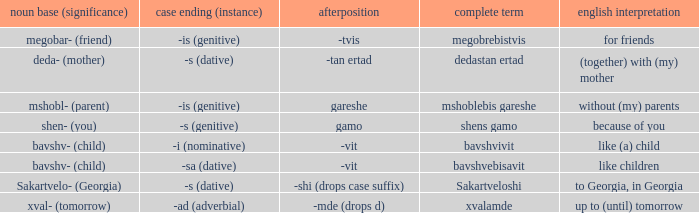Can you give me this table as a dict? {'header': ['noun base (significance)', 'case ending (instance)', 'afterposition', 'complete term', 'english interpretation'], 'rows': [['megobar- (friend)', '-is (genitive)', '-tvis', 'megobrebistvis', 'for friends'], ['deda- (mother)', '-s (dative)', '-tan ertad', 'dedastan ertad', '(together) with (my) mother'], ['mshobl- (parent)', '-is (genitive)', 'gareshe', 'mshoblebis gareshe', 'without (my) parents'], ['shen- (you)', '-s (genitive)', 'gamo', 'shens gamo', 'because of you'], ['bavshv- (child)', '-i (nominative)', '-vit', 'bavshvivit', 'like (a) child'], ['bavshv- (child)', '-sa (dative)', '-vit', 'bavshvebisavit', 'like children'], ['Sakartvelo- (Georgia)', '-s (dative)', '-shi (drops case suffix)', 'Sakartveloshi', 'to Georgia, in Georgia'], ['xval- (tomorrow)', '-ad (adverbial)', '-mde (drops d)', 'xvalamde', 'up to (until) tomorrow']]} What is Case Suffix (Case), when English Meaning is "to Georgia, in Georgia"? -s (dative). 